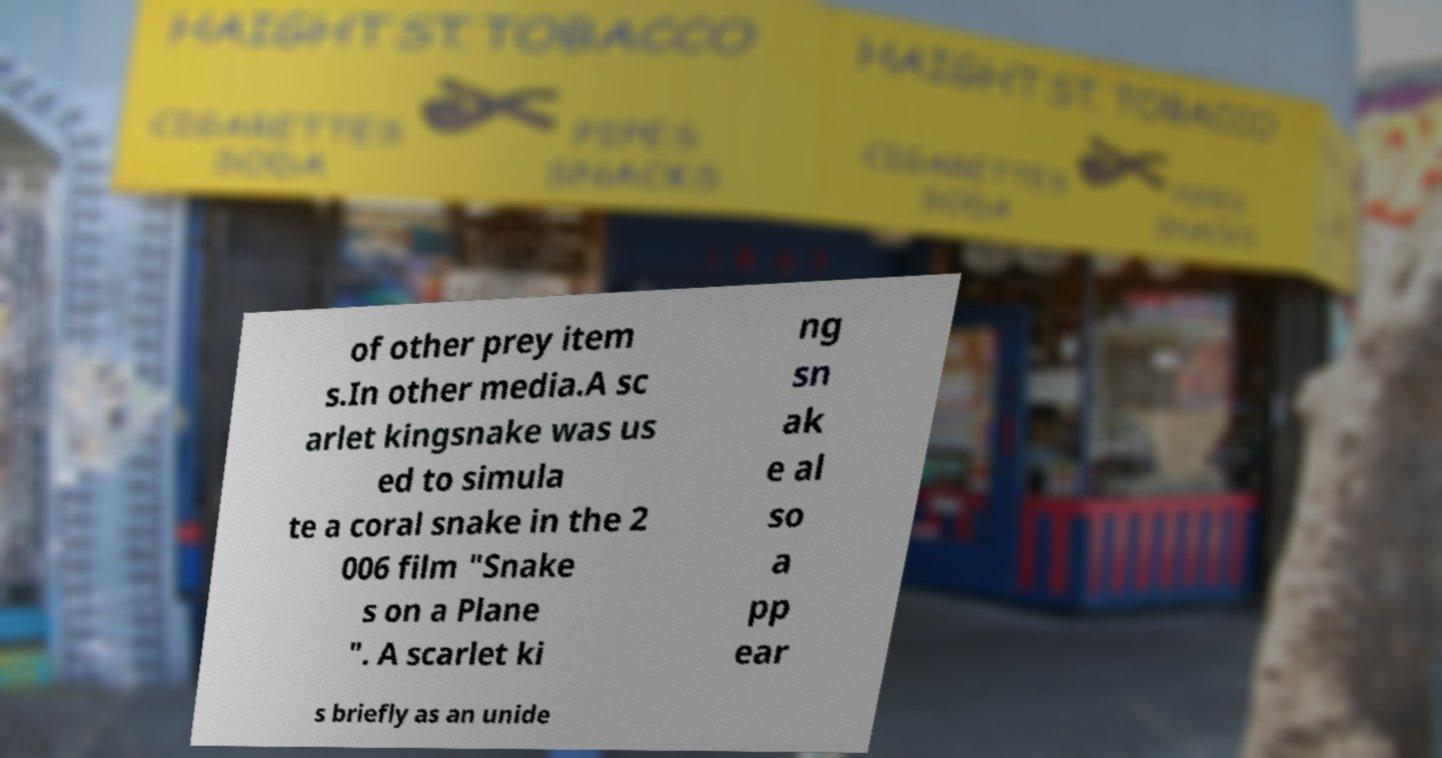Could you extract and type out the text from this image? of other prey item s.In other media.A sc arlet kingsnake was us ed to simula te a coral snake in the 2 006 film "Snake s on a Plane ". A scarlet ki ng sn ak e al so a pp ear s briefly as an unide 